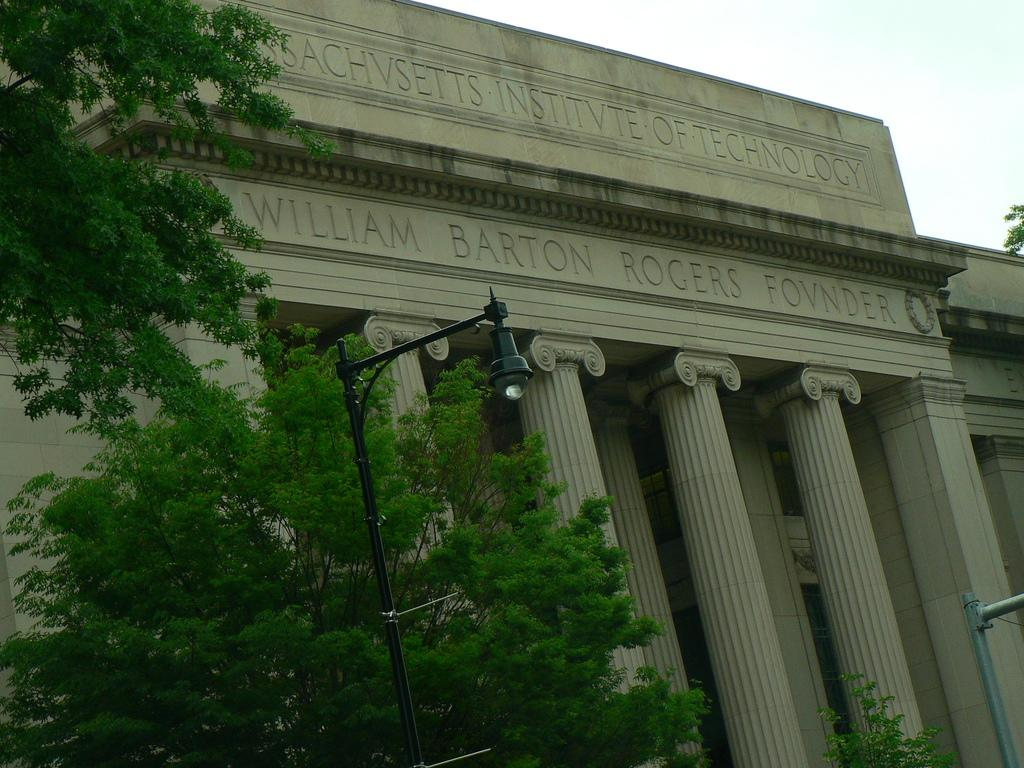What type of vegetation is present in the image? There are trees in the image. What structures can be seen in the image? There are light poles and a stone building in the image. What is visible in the background of the image? The sky is visible in the background of the image. What arithmetic problem is being solved on the stone building in the image? There is no arithmetic problem visible on the stone building in the image. What type of pan can be seen hanging from the trees in the image? There are no pans present in the image; it features trees, light poles, a stone building, and the sky. 